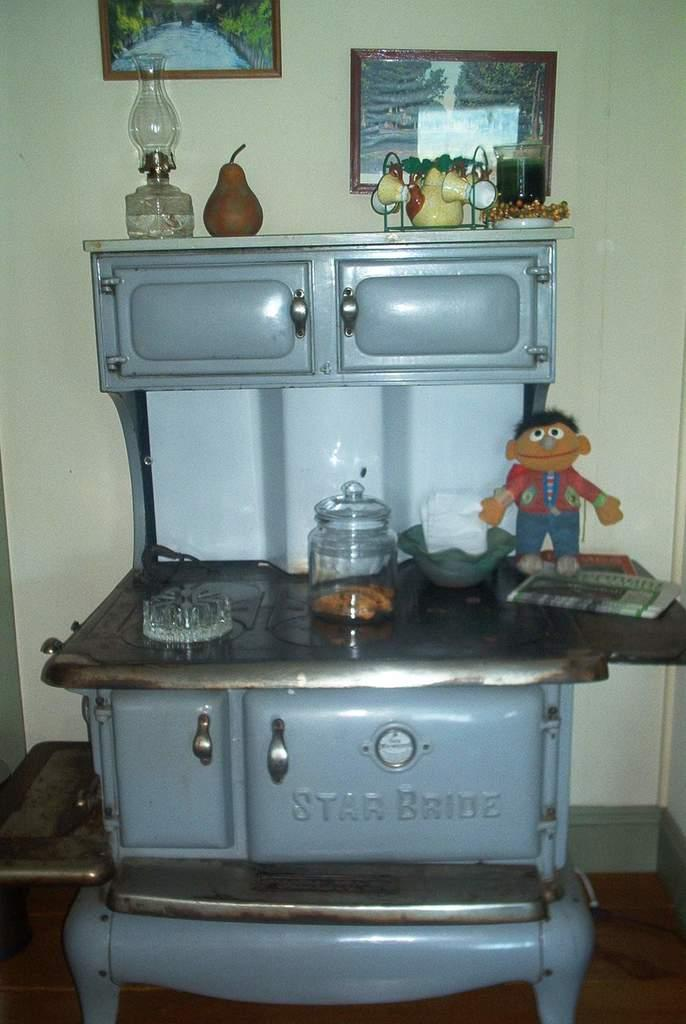Provide a one-sentence caption for the provided image. an old Star Bride stove is being used to hold many things including Ernie from Sesame street. 